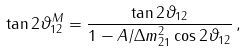Convert formula to latex. <formula><loc_0><loc_0><loc_500><loc_500>\tan 2 \vartheta _ { 1 2 } ^ { M } = \frac { \tan 2 \vartheta _ { 1 2 } } { 1 - A / \Delta { m } ^ { 2 } _ { 2 1 } \cos { 2 \vartheta _ { 1 2 } } } \, ,</formula> 